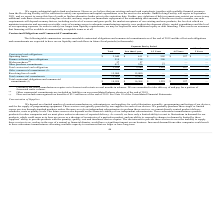From Quicklogic Corporation's financial document, What are the respective values of operating leases due in less than 1 year and between 1 to 3 years? The document shows two values: $611 and $902 (in thousands). From the document: "Operating leases $ 2,040 $ 611 $ 902 $ 527 $ — Operating leases $ 2,040 $ 611 $ 902 $ 527 $ —..." Also, What are the respective values of finance software lease obligations due in less than 1 year and between 1 to 3 years? The document shows two values: 214 and 300 (in thousands). From the document: "Finance software lease obligations 514 214 300 — — Finance software lease obligations 514 214 300 — —..." Also, What are the respective values of the company's total contractual cash obligations due in less than 1 year and between 1 to 3 years? The document shows two values: 1,268 and 1,229 (in thousands). From the document: "Total contractual cash obligations 3,024 1,268 1,229 527 — Total contractual cash obligations 3,024 1,268 1,229 527 —..." Also, can you calculate: What is the average operating leases due in less than 1 year and between 1 to 3 years? To answer this question, I need to perform calculations using the financial data. The calculation is: ($611 + $902)/2 , which equals 756.5 (in thousands). This is based on the information: "Operating leases $ 2,040 $ 611 $ 902 $ 527 $ — Operating leases $ 2,040 $ 611 $ 902 $ 527 $ —..." The key data points involved are: 611, 902. Also, can you calculate: What is the average finance software lease obligations due in less than 1 year and between 1 to 3 years? To answer this question, I need to perform calculations using the financial data. The calculation is: (214 + 300)/2 , which equals 257 (in thousands). This is based on the information: "Finance software lease obligations 514 214 300 — — Finance software lease obligations 514 214 300 — —..." The key data points involved are: 214, 300. Also, can you calculate: What is the average  total contractual cash obligations due in less than 1 year and between 1 to 3 years? To answer this question, I need to perform calculations using the financial data. The calculation is: (1,268 + 1,229)/2 , which equals 1248.5 (in thousands). This is based on the information: "Total contractual cash obligations 3,024 1,268 1,229 527 — Total contractual cash obligations 3,024 1,268 1,229 527 —..." The key data points involved are: 1,229, 1,268. 